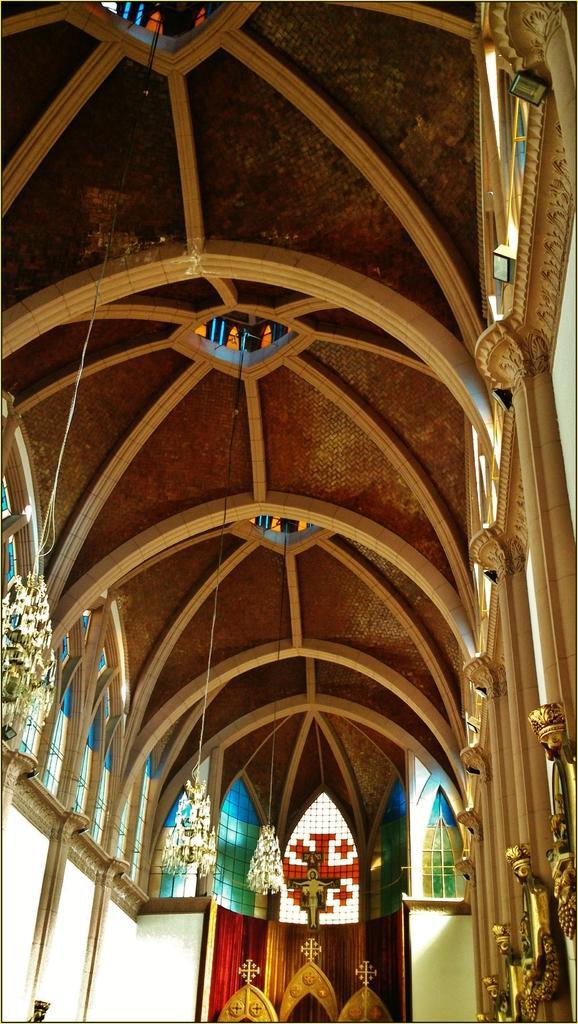Please provide a concise description of this image. This is an inside view of a building. In this picture we can see some glass objects and golden objects on the right side. It looks like a chandelier on the left side. 